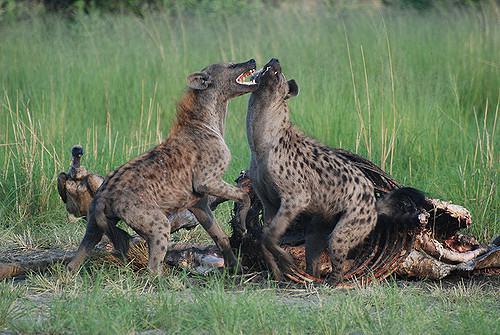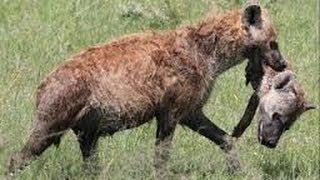The first image is the image on the left, the second image is the image on the right. For the images shown, is this caption "There are at least three hyenas eating  a dead animal." true? Answer yes or no. No. 